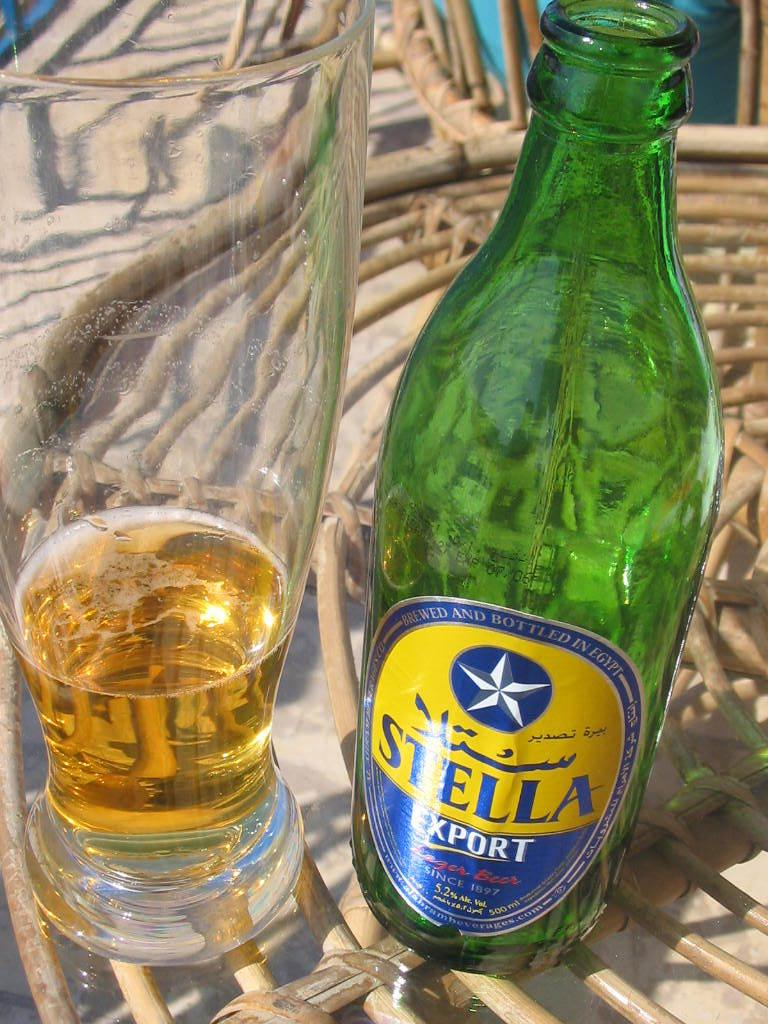<image>
Give a short and clear explanation of the subsequent image. A green glas bottle labeled Stella Export sits on a wicker table next to a nearly empty beer glass. 